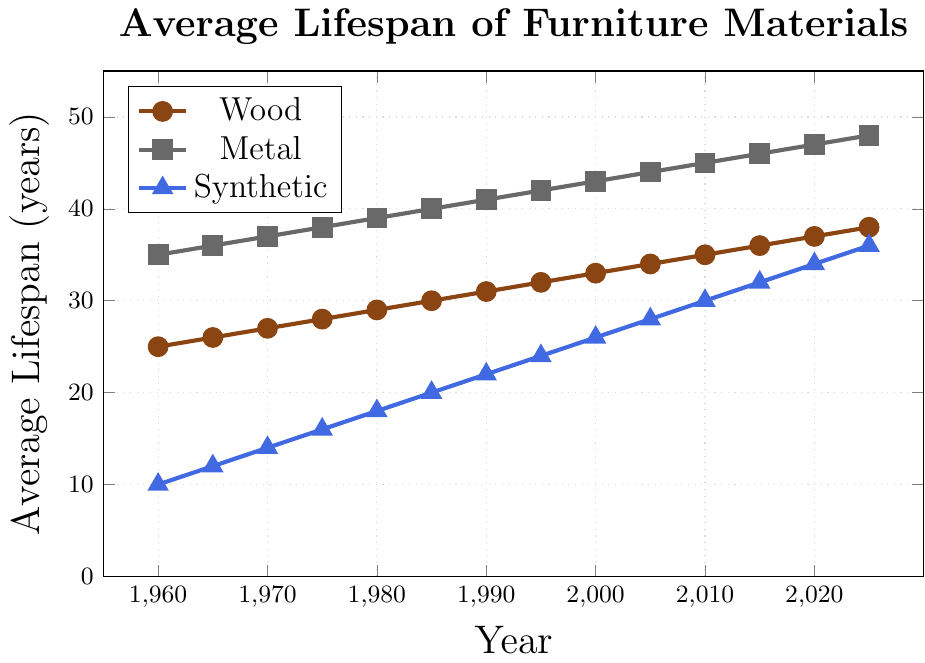Which material has the longest average lifespan in 1980? In 1980, the average lifespan of wood, metal, and synthetic materials can be compared by examining their respective data points: wood (29 years), metal (39 years), and synthetic (18 years). Metal has the longest average lifespan.
Answer: Metal What is the difference in average lifespan between metal and synthetic materials in 2000? The average lifespan in 2000 for metal is 43 years, and for synthetic materials, it is 26 years. The difference is calculated by subtracting 26 from 43.
Answer: 17 years How much has the average lifespan of wood increased from 1960 to 2025? In 1960, the average lifespan of wood is 25 years, and in 2025, it is 38 years. The increase is found by subtracting 25 from 38.
Answer: 13 years Which material shows the most significant increase in average lifespan from 1960 to 2025? Comparing the increases: Wood increases from 25 to 38 years (13 years), Metal from 35 to 48 years (13 years), Synthetic from 10 to 36 years (26 years). Synthetic shows the largest increase.
Answer: Synthetic By how much did the average lifespan of synthetic materials change between 1975 and 1985? In 1975, the average lifespan of synthetic materials is 16 years, and in 1985, it is 20 years. The change is calculated by subtracting 16 from 20.
Answer: 4 years Which material has a higher average lifespan in 2015, wood or synthetic? By how many years? In 2015, the average lifespan of wood is 36 years, and for synthetic materials, it is 32 years. The difference is calculated by subtracting 32 from 36.
Answer: Wood, by 4 years Between which two consecutive years does metal show the least increase in average lifespan? By examining the increases between consecutive years: all increments are 1 year for metal. Hence, it consistently increases by the same amount each period.
Answer: None (Consistent increase) How does the average lifespan trend for each material over time? The average lifespans for wood, metal, and synthetic materials all show an increasing trend over time. This can be clearly seen by the upward slopes of each respective line on the plot.
Answer: Increasing trend for all materials 